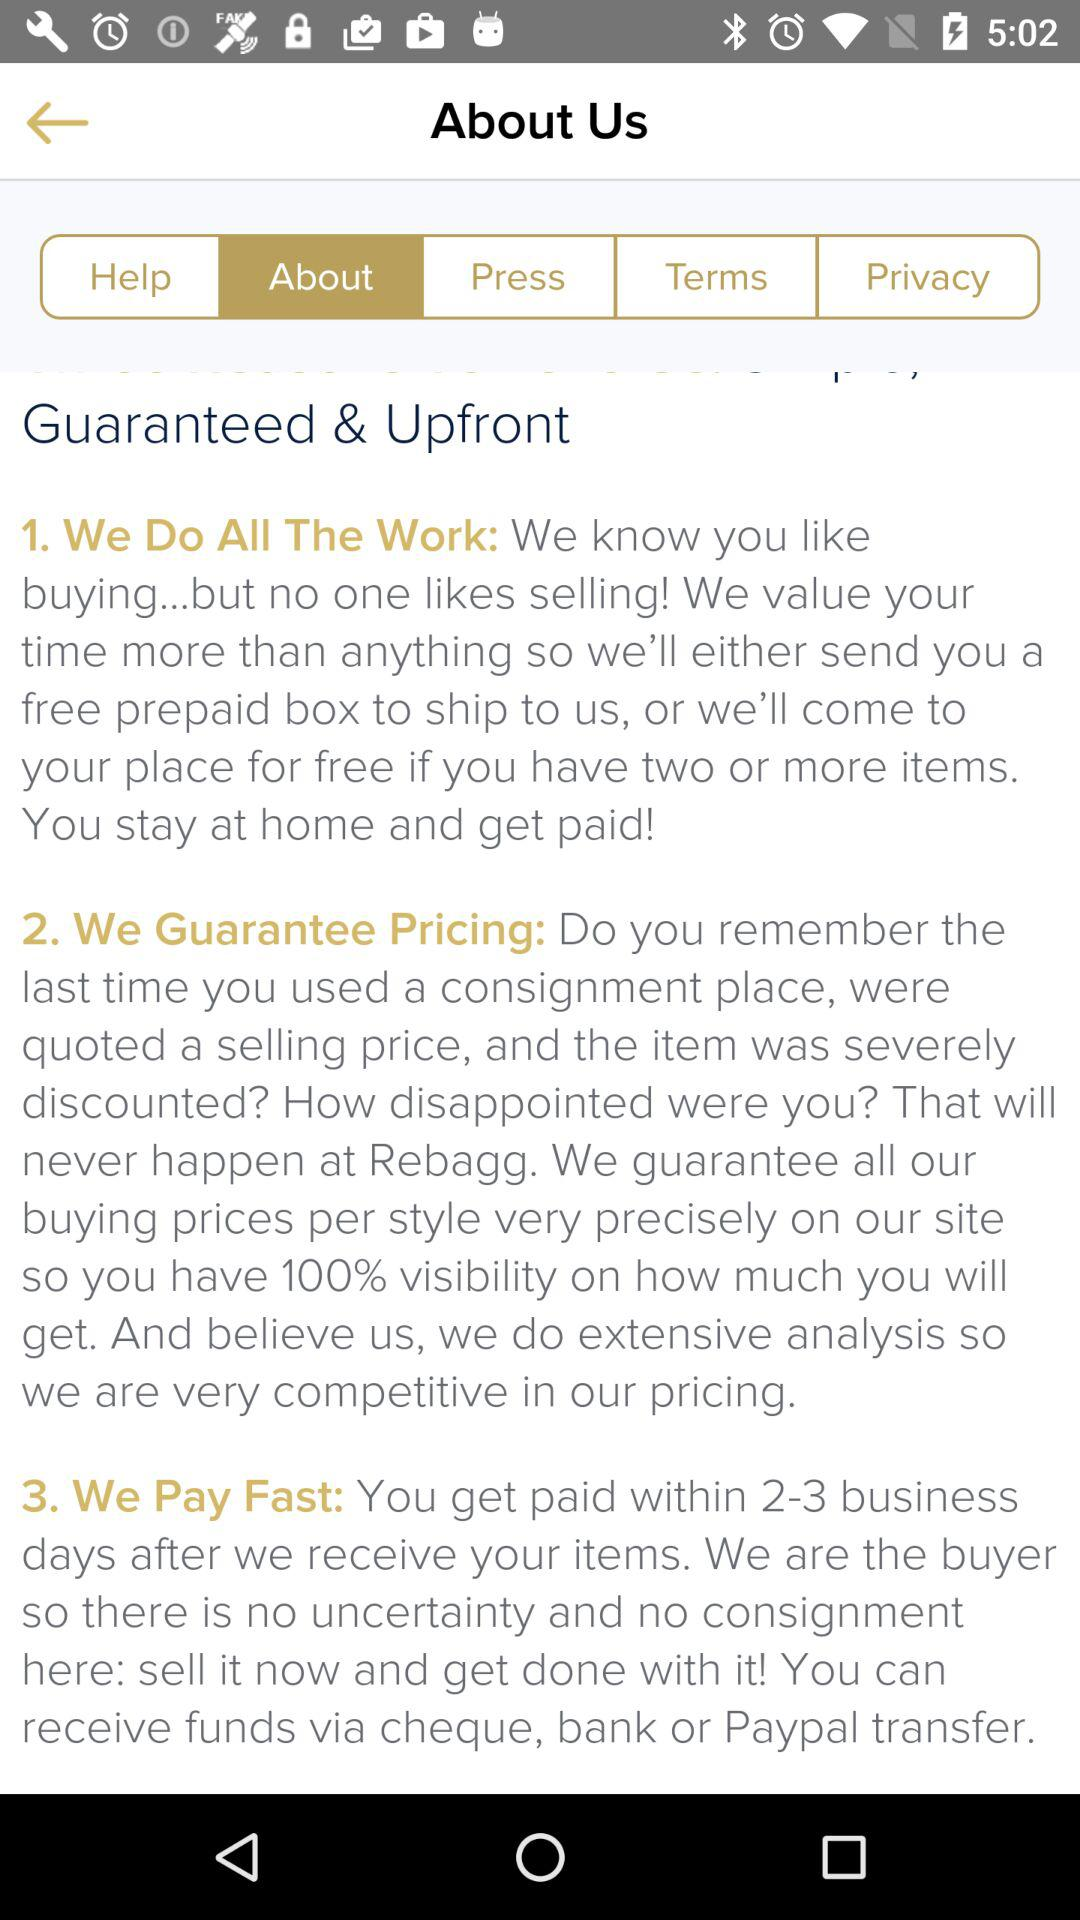Which tab is selected? The selected tab is "About". 